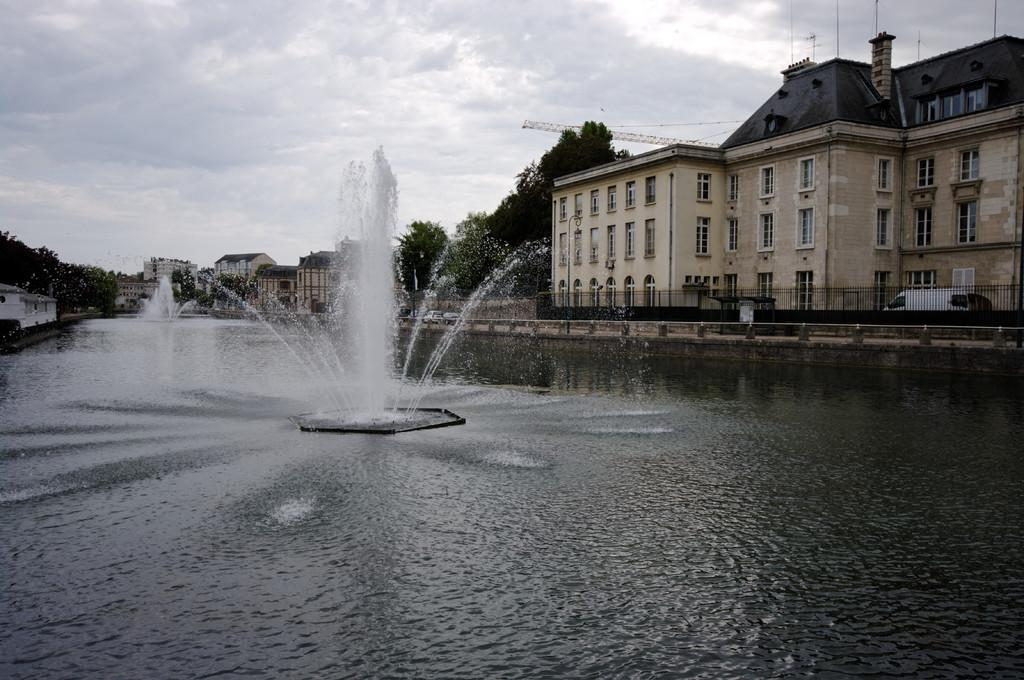What is the main element present in the image? There is water in the image. What structures can be seen in the center of the image? There are fountains in the center of the image. What type of buildings are visible on the sides of the image? There are buildings with windows on the sides of the image. What type of vegetation is present in the image? There are trees in the image. What feature can be seen near the water's edge? There is a railing in the image. What can be seen in the background of the image? The sky is visible in the background of the image. How does the water affect the person's cough in the image? There is no person or cough present in the image; it features water, fountains, buildings, trees, a railing, and the sky. 